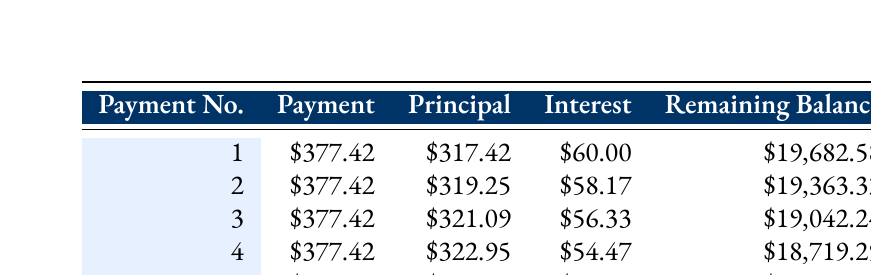What is the payment amount for the first installment? The payment amount is listed in the first row of the table under the "Payment" column for Payment No. 1. It shows \$377.42.
Answer: 377.42 How much principal is paid in the second payment? The principal portion for the second payment can be found in the second row of the "Principal" column. It indicates \$319.25.
Answer: 319.25 What is the total interest paid in the first five payments? To find the total interest, we need to sum the interest amounts from each of the five payments: \$60.00 + \$58.17 + \$56.33 + \$54.47 + \$52.61 = \$281.58.
Answer: 281.58 Is the payment amount consistent throughout the schedule? All payment amounts are the same at \$377.42 across all payment numbers, indicating consistency.
Answer: Yes What is the remaining balance after the fourth payment? The remaining balance after the fourth payment can be found in the fourth row of the "Remaining Balance" column, which shows \$18,719.29.
Answer: 18719.29 How much interest is paid in the third payment? The interest for the third payment can be found in the third row of the "Interest" column, and it indicates \$56.33.
Answer: 56.33 What is the total principal paid after the first three payments? To calculate the total principal paid, sum the principal amounts from the first three payments: \$317.42 + \$319.25 + \$321.09 = \$957.76.
Answer: 957.76 What is the difference in principal paid between the first and fifth payments? The principal paid in the first payment is \$317.42, and the principal in the fifth payment is \$324.81. The difference is \$324.81 - \$317.42 = \$7.39.
Answer: 7.39 How much of the second payment goes towards interest? The interest portion of the second payment can be found in the second row under the "Interest" column, which is \$58.17.
Answer: 58.17 